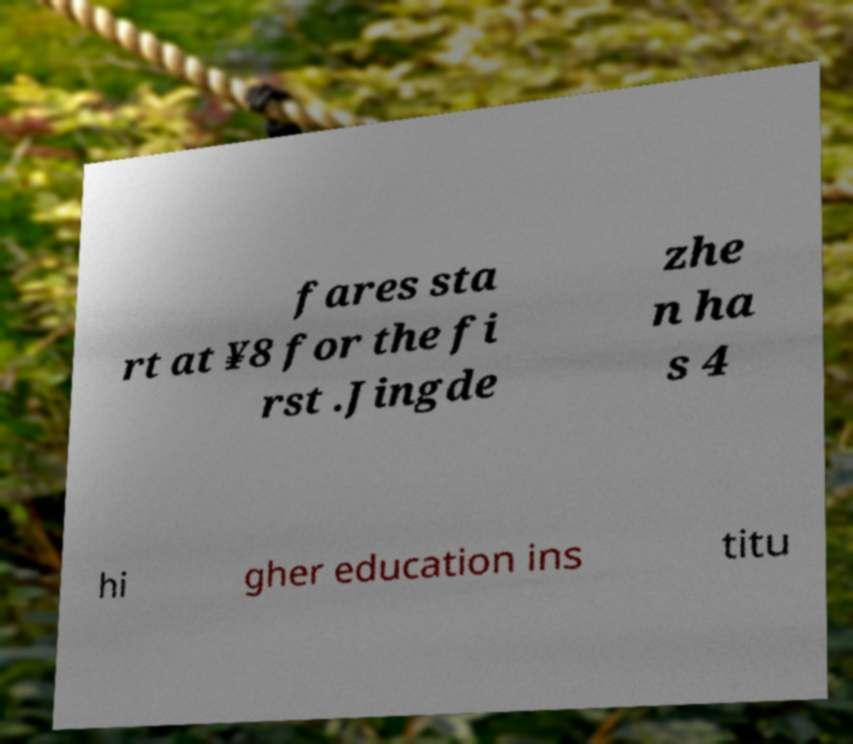Please read and relay the text visible in this image. What does it say? fares sta rt at ¥8 for the fi rst .Jingde zhe n ha s 4 hi gher education ins titu 